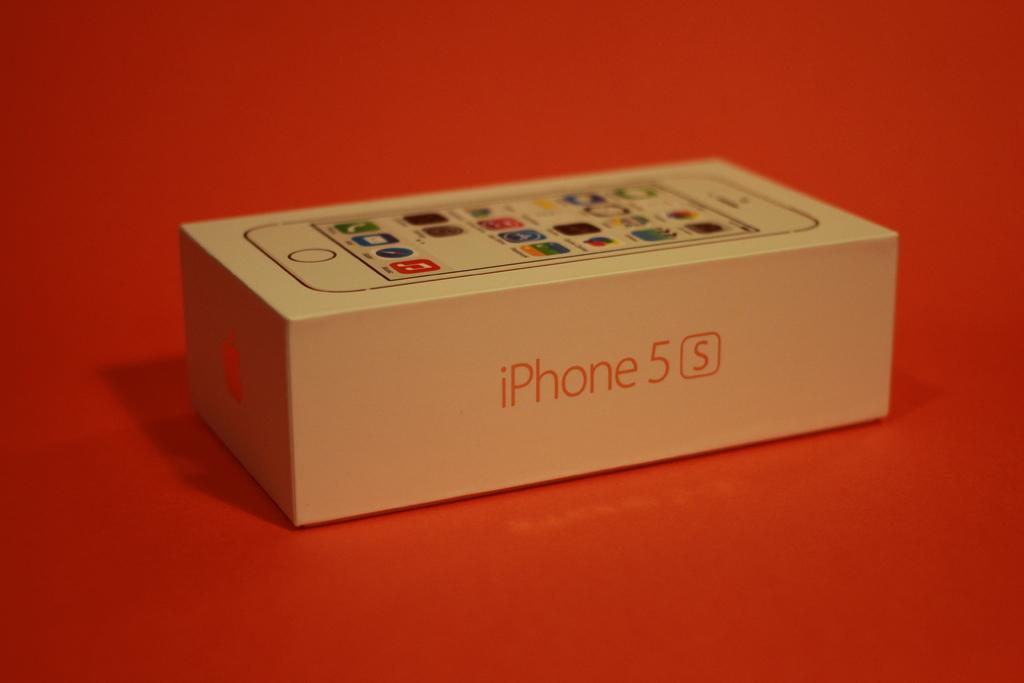What type of phone is tis for?
Keep it short and to the point. Iphone 5s. What type of iphone 5 is it?
Your answer should be compact. S. 